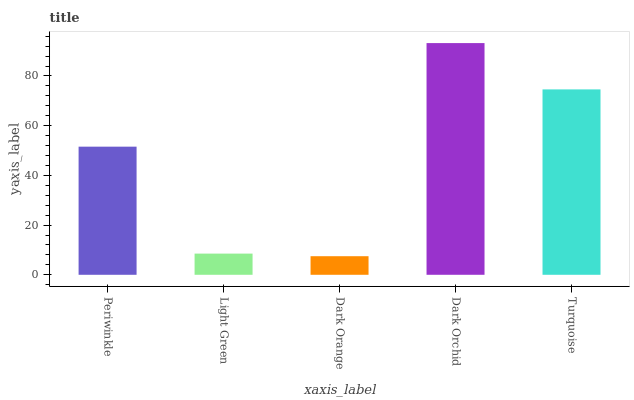Is Dark Orange the minimum?
Answer yes or no. Yes. Is Dark Orchid the maximum?
Answer yes or no. Yes. Is Light Green the minimum?
Answer yes or no. No. Is Light Green the maximum?
Answer yes or no. No. Is Periwinkle greater than Light Green?
Answer yes or no. Yes. Is Light Green less than Periwinkle?
Answer yes or no. Yes. Is Light Green greater than Periwinkle?
Answer yes or no. No. Is Periwinkle less than Light Green?
Answer yes or no. No. Is Periwinkle the high median?
Answer yes or no. Yes. Is Periwinkle the low median?
Answer yes or no. Yes. Is Dark Orange the high median?
Answer yes or no. No. Is Dark Orchid the low median?
Answer yes or no. No. 